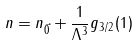<formula> <loc_0><loc_0><loc_500><loc_500>n = n _ { \vec { 0 } } + \frac { 1 } { \Lambda ^ { 3 } } g _ { 3 / 2 } ( 1 )</formula> 